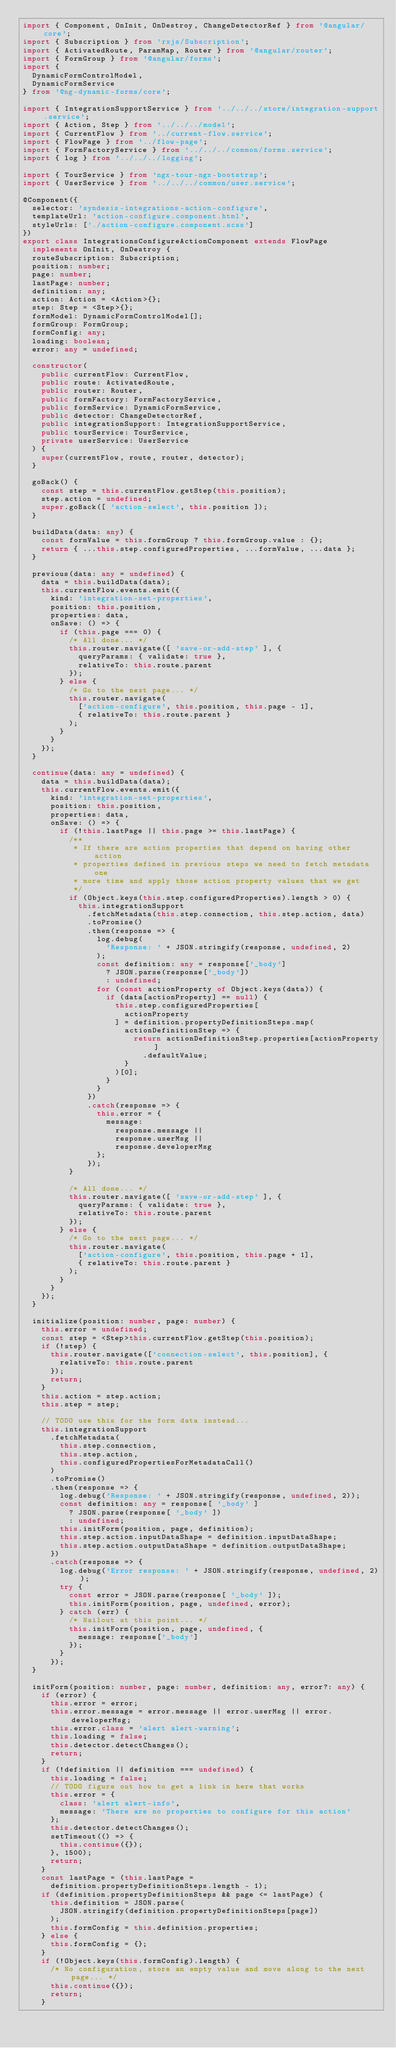Convert code to text. <code><loc_0><loc_0><loc_500><loc_500><_TypeScript_>import { Component, OnInit, OnDestroy, ChangeDetectorRef } from '@angular/core';
import { Subscription } from 'rxjs/Subscription';
import { ActivatedRoute, ParamMap, Router } from '@angular/router';
import { FormGroup } from '@angular/forms';
import {
  DynamicFormControlModel,
  DynamicFormService
} from '@ng-dynamic-forms/core';

import { IntegrationSupportService } from '../../../store/integration-support.service';
import { Action, Step } from '../../../model';
import { CurrentFlow } from '../current-flow.service';
import { FlowPage } from '../flow-page';
import { FormFactoryService } from '../../../common/forms.service';
import { log } from '../../../logging';

import { TourService } from 'ngx-tour-ngx-bootstrap';
import { UserService } from '../../../common/user.service';

@Component({
  selector: 'syndesis-integrations-action-configure',
  templateUrl: 'action-configure.component.html',
  styleUrls: ['./action-configure.component.scss']
})
export class IntegrationsConfigureActionComponent extends FlowPage
  implements OnInit, OnDestroy {
  routeSubscription: Subscription;
  position: number;
  page: number;
  lastPage: number;
  definition: any;
  action: Action = <Action>{};
  step: Step = <Step>{};
  formModel: DynamicFormControlModel[];
  formGroup: FormGroup;
  formConfig: any;
  loading: boolean;
  error: any = undefined;

  constructor(
    public currentFlow: CurrentFlow,
    public route: ActivatedRoute,
    public router: Router,
    public formFactory: FormFactoryService,
    public formService: DynamicFormService,
    public detector: ChangeDetectorRef,
    public integrationSupport: IntegrationSupportService,
    public tourService: TourService,
    private userService: UserService
  ) {
    super(currentFlow, route, router, detector);
  }

  goBack() {
    const step = this.currentFlow.getStep(this.position);
    step.action = undefined;
    super.goBack([ 'action-select', this.position ]);
  }

  buildData(data: any) {
    const formValue = this.formGroup ? this.formGroup.value : {};
    return { ...this.step.configuredProperties, ...formValue, ...data };
  }

  previous(data: any = undefined) {
    data = this.buildData(data);
    this.currentFlow.events.emit({
      kind: 'integration-set-properties',
      position: this.position,
      properties: data,
      onSave: () => {
        if (this.page === 0) {
          /* All done... */
          this.router.navigate([ 'save-or-add-step' ], {
            queryParams: { validate: true },
            relativeTo: this.route.parent
          });
        } else {
          /* Go to the next page... */
          this.router.navigate(
            ['action-configure', this.position, this.page - 1],
            { relativeTo: this.route.parent }
          );
        }
      }
    });
  }

  continue(data: any = undefined) {
    data = this.buildData(data);
    this.currentFlow.events.emit({
      kind: 'integration-set-properties',
      position: this.position,
      properties: data,
      onSave: () => {
        if (!this.lastPage || this.page >= this.lastPage) {
          /**
           * If there are action properties that depend on having other action
           * properties defined in previous steps we need to fetch metadata one
           * more time and apply those action property values that we get
           */
          if (Object.keys(this.step.configuredProperties).length > 0) {
            this.integrationSupport
              .fetchMetadata(this.step.connection, this.step.action, data)
              .toPromise()
              .then(response => {
                log.debug(
                  'Response: ' + JSON.stringify(response, undefined, 2)
                );
                const definition: any = response['_body']
                  ? JSON.parse(response['_body'])
                  : undefined;
                for (const actionProperty of Object.keys(data)) {
                  if (data[actionProperty] == null) {
                    this.step.configuredProperties[
                      actionProperty
                    ] = definition.propertyDefinitionSteps.map(
                      actionDefinitionStep => {
                        return actionDefinitionStep.properties[actionProperty]
                          .defaultValue;
                      }
                    )[0];
                  }
                }
              })
              .catch(response => {
                this.error = {
                  message:
                    response.message ||
                    response.userMsg ||
                    response.developerMsg
                };
              });
          }

          /* All done... */
          this.router.navigate([ 'save-or-add-step' ], {
            queryParams: { validate: true },
            relativeTo: this.route.parent
          });
        } else {
          /* Go to the next page... */
          this.router.navigate(
            ['action-configure', this.position, this.page + 1],
            { relativeTo: this.route.parent }
          );
        }
      }
    });
  }

  initialize(position: number, page: number) {
    this.error = undefined;
    const step = <Step>this.currentFlow.getStep(this.position);
    if (!step) {
      this.router.navigate(['connection-select', this.position], {
        relativeTo: this.route.parent
      });
      return;
    }
    this.action = step.action;
    this.step = step;

    // TODO use this for the form data instead...
    this.integrationSupport
      .fetchMetadata(
        this.step.connection,
        this.step.action,
        this.configuredPropertiesForMetadataCall()
      )
      .toPromise()
      .then(response => {
        log.debug('Response: ' + JSON.stringify(response, undefined, 2));
        const definition: any = response[ '_body' ]
          ? JSON.parse(response[ '_body' ])
          : undefined;
        this.initForm(position, page, definition);
        this.step.action.inputDataShape = definition.inputDataShape;
        this.step.action.outputDataShape = definition.outputDataShape;
      })
      .catch(response => {
        log.debug('Error response: ' + JSON.stringify(response, undefined, 2));
        try {
          const error = JSON.parse(response[ '_body' ]);
          this.initForm(position, page, undefined, error);
        } catch (err) {
          /* Nailout at this point... */
          this.initForm(position, page, undefined, {
            message: response['_body']
          });
        }
      });
  }

  initForm(position: number, page: number, definition: any, error?: any) {
    if (error) {
      this.error = error;
      this.error.message = error.message || error.userMsg || error.developerMsg;
      this.error.class = 'alert alert-warning';
      this.loading = false;
      this.detector.detectChanges();
      return;
    }
    if (!definition || definition === undefined) {
      this.loading = false;
      // TODO figure out how to get a link in here that works
      this.error = {
        class: 'alert alert-info',
        message: 'There are no properties to configure for this action'
      };
      this.detector.detectChanges();
      setTimeout(() => {
        this.continue({});
      }, 1500);
      return;
    }
    const lastPage = (this.lastPage =
      definition.propertyDefinitionSteps.length - 1);
    if (definition.propertyDefinitionSteps && page <= lastPage) {
      this.definition = JSON.parse(
        JSON.stringify(definition.propertyDefinitionSteps[page])
      );
      this.formConfig = this.definition.properties;
    } else {
      this.formConfig = {};
    }
    if (!Object.keys(this.formConfig).length) {
      /* No configuration, store an empty value and move along to the next page... */
      this.continue({});
      return;
    }</code> 